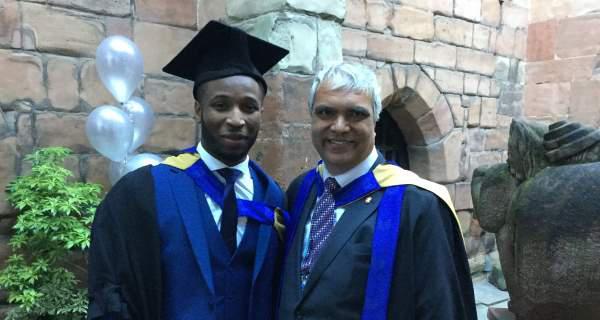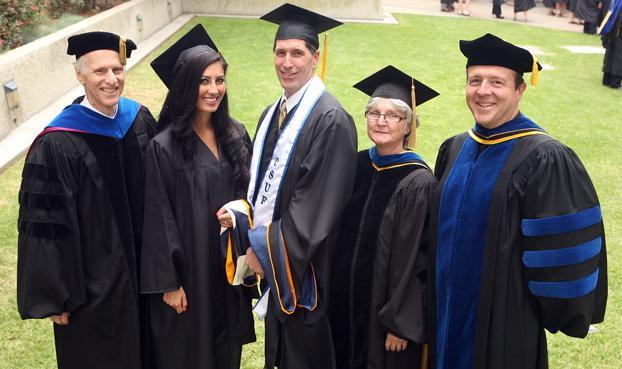The first image is the image on the left, the second image is the image on the right. Examine the images to the left and right. Is the description "The people in the image on the right are standing near trees." accurate? Answer yes or no. No. The first image is the image on the left, the second image is the image on the right. For the images shown, is this caption "The left image contains only males, posed side-to-side facing forward, and at least one of them is a black man wearing a graduation cap." true? Answer yes or no. Yes. 